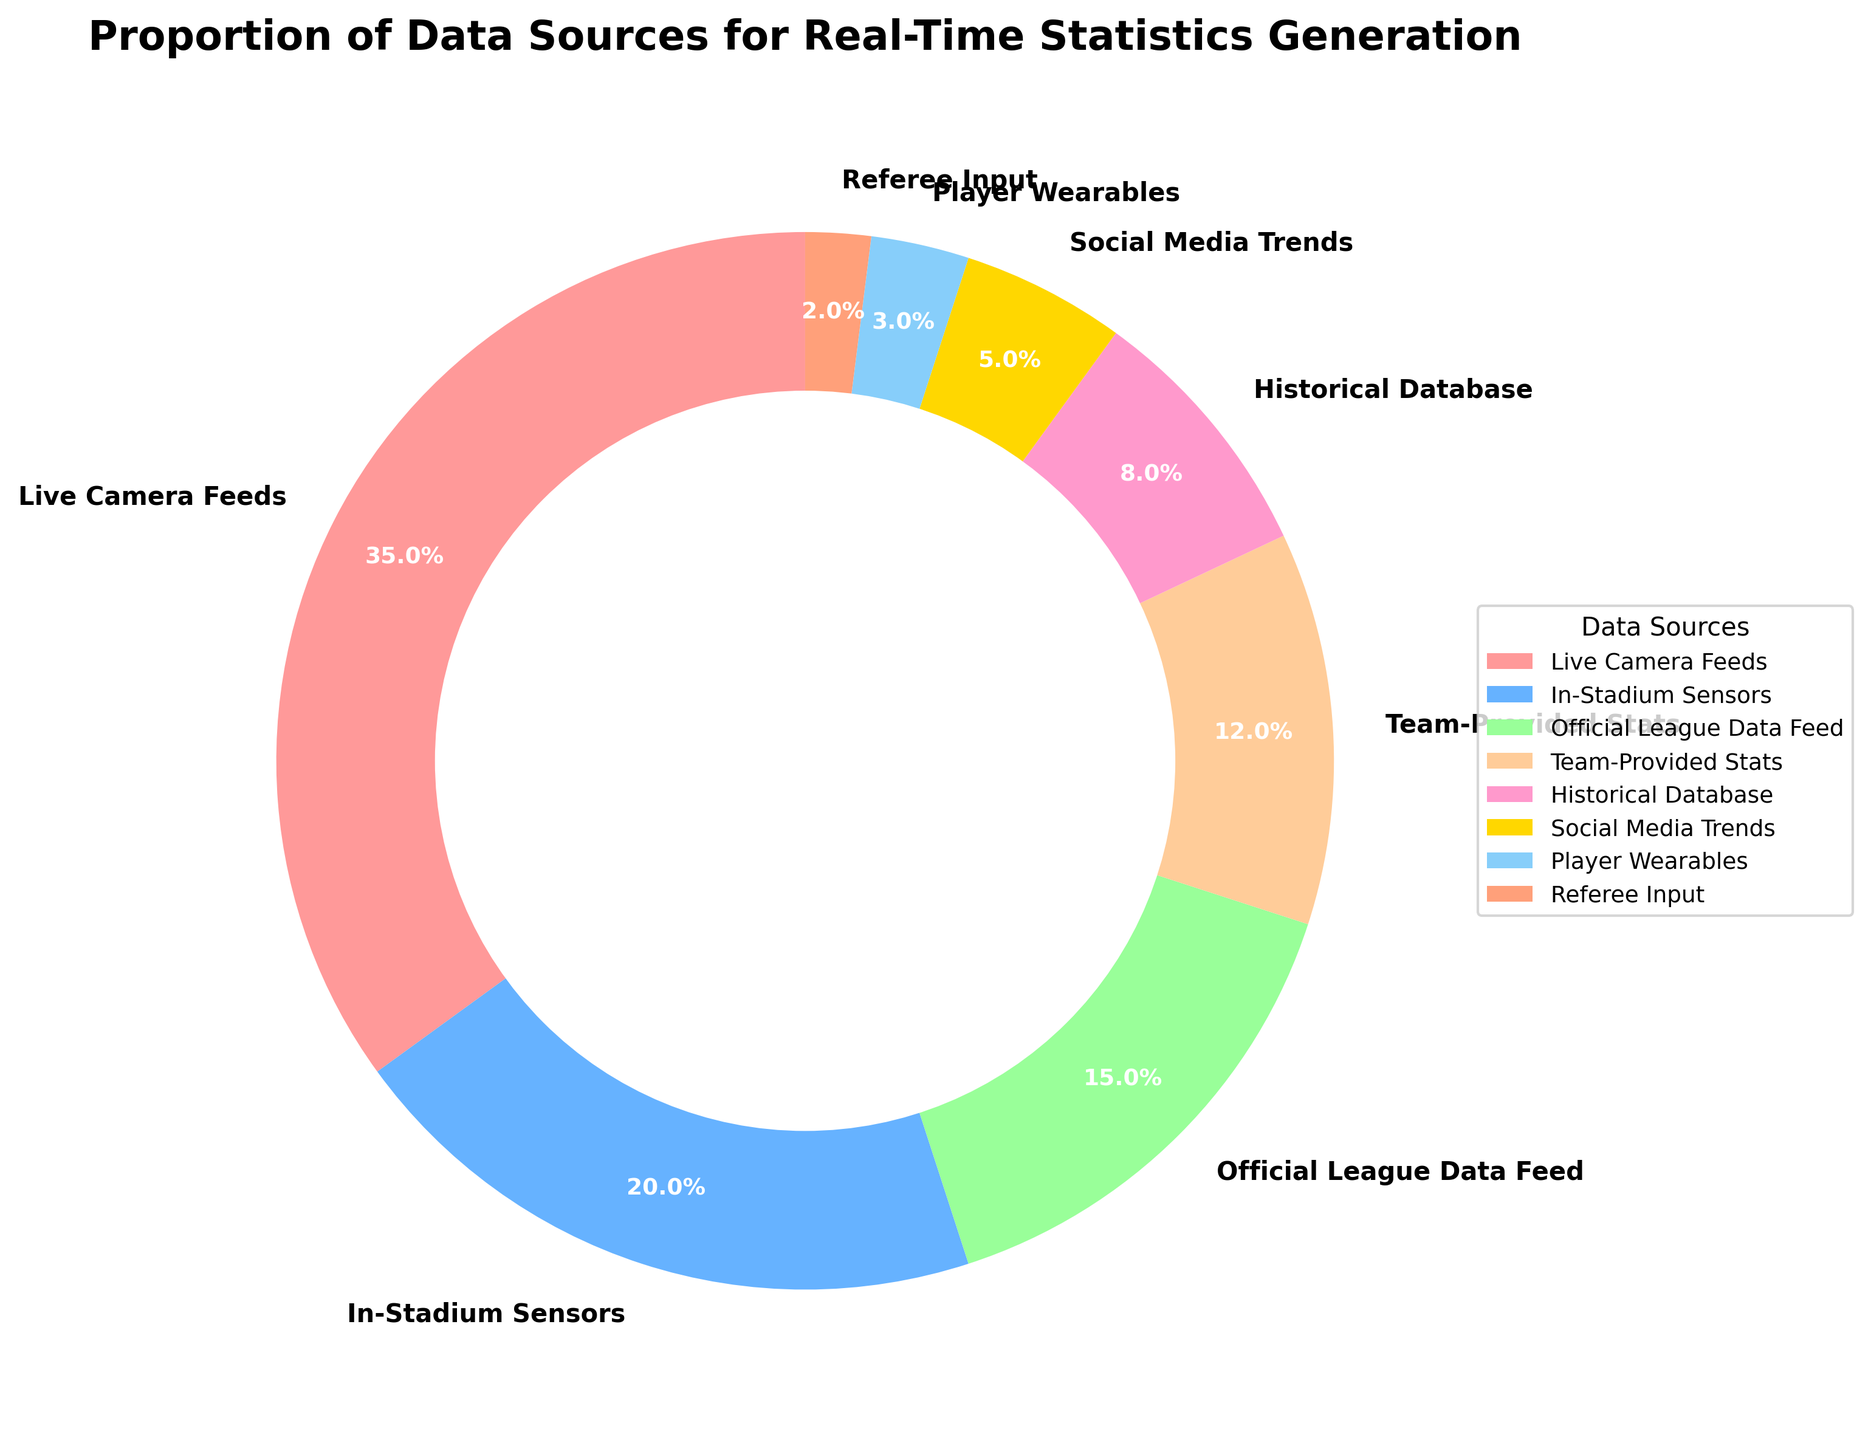What is the largest data source used for real-time statistics generation? By looking at the pie chart, the largest wedge corresponds to the "Live Camera Feeds" section, which is labeled with 35%.
Answer: Live Camera Feeds How much more data does "Live Camera Feeds" provide compared to "In-Stadium Sensors"? The "Live Camera Feeds" provides 35%, and the "In-Stadium Sensors" provide 20%. Subtracting these values gives 35% - 20% = 15%.
Answer: 15% Which data source contributes the least to real-time statistics generation? In the pie chart, the smallest wedge corresponds to "Referee Input," which is labeled with 2%.
Answer: Referee Input What is the combined percentage of "Player Wearables" and "Team-Provided Stats"? The "Player Wearables" contributes 3% and "Team-Provided Stats" contributes 12%. Adding these percentages gives 3% + 12% = 15%.
Answer: 15% Which is greater, the percentage of data from "Official League Data Feed" or the sum of "Historical Database" and "Social Media Trends"? "Official League Data Feed" is 15%. Adding "Historical Database" (8%) and "Social Media Trends" (5%) gives 8% + 5% = 13%. "Official League Data Feed" is greater.
Answer: Official League Data Feed What is the difference in percentage between the "Live Camera Feeds" and "Historical Database"? The "Live Camera Feeds" provides 35%, and the "Historical Database" provides 8%. Subtracting these values gives 35% - 8% = 27%.
Answer: 27% Are "In-Stadium Sensors" and "Team-Provided Stats" together contributing more than "Live Camera Feeds" alone? "In-Stadium Sensors" contributes 20% and "Team-Provided Stats" contributes 12%. Adding these gives 20% + 12% = 32%, which is less than the 35% from "Live Camera Feeds".
Answer: No Which segment is represented by the green color in the pie chart? According to the color pattern in the description, the green color corresponds to the "In-Stadium Sensors" section.
Answer: In-Stadium Sensors What is the middle value of the three largest data source percentages? The three largest percentages are "Live Camera Feeds" (35%), "In-Stadium Sensors" (20%), and "Official League Data Feed" (15%). The middle value among these is 20%.
Answer: 20% How does the contribution of "Social Media Trends" compare to that of "Player Wearables"? "Social Media Trends" contributes 5% and "Player Wearables" contributes 3%. 5% is greater than 3%.
Answer: Social Media Trends 